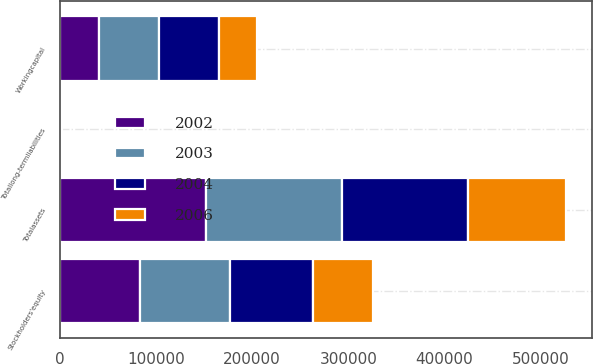Convert chart to OTSL. <chart><loc_0><loc_0><loc_500><loc_500><stacked_bar_chart><ecel><fcel>Workingcapital<fcel>Totalassets<fcel>Totallong-termliabilities<fcel>Stockholders'equity<nl><fcel>2002<fcel>40306<fcel>151558<fcel>219<fcel>83556<nl><fcel>2003<fcel>62978<fcel>142110<fcel>64<fcel>93438<nl><fcel>2004<fcel>61886<fcel>130712<fcel>25<fcel>85739<nl><fcel>2006<fcel>39737<fcel>102202<fcel>1849<fcel>62976<nl></chart> 